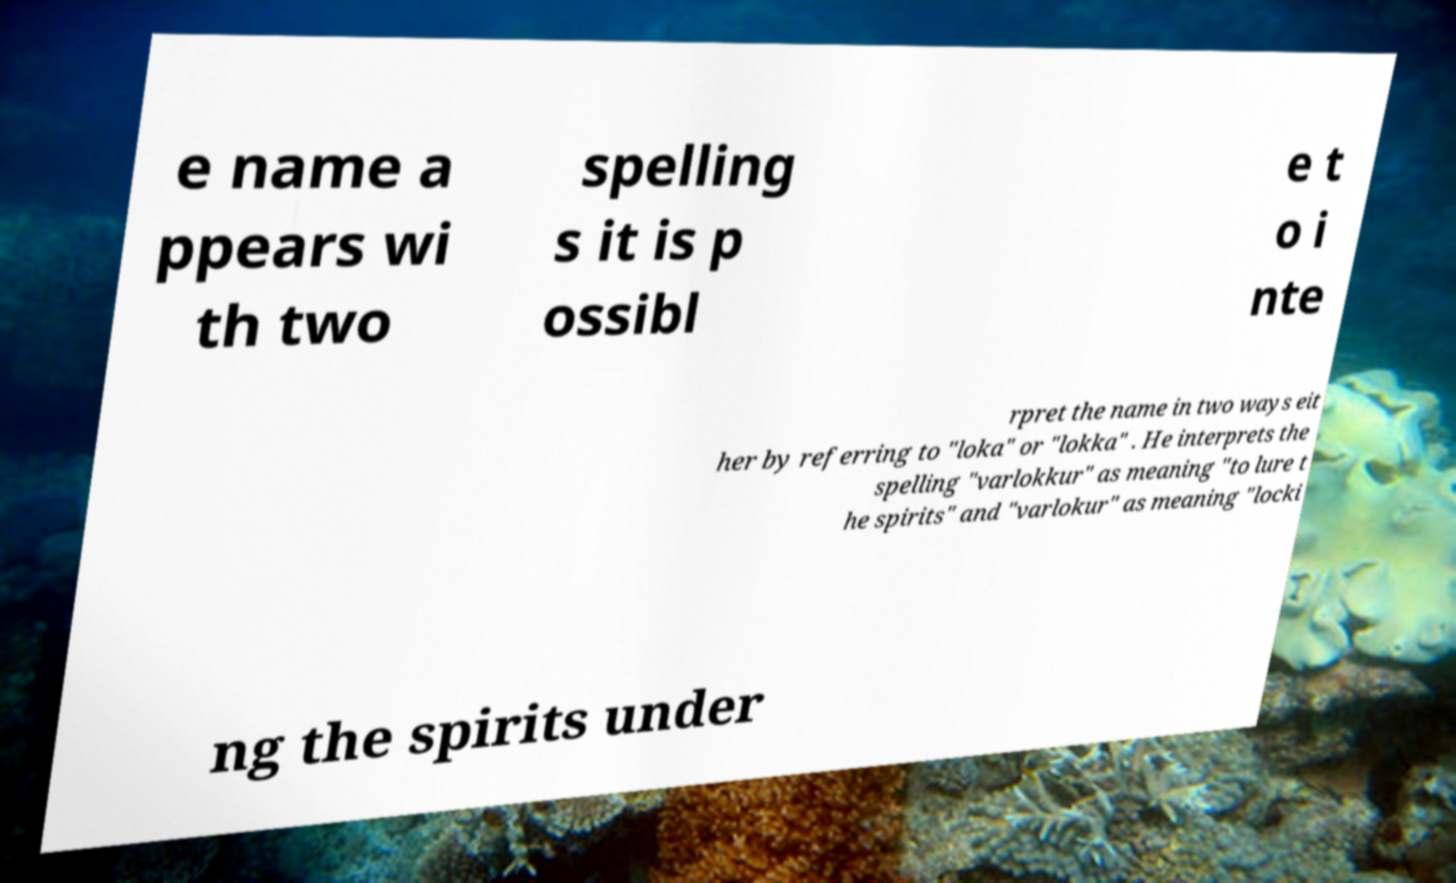There's text embedded in this image that I need extracted. Can you transcribe it verbatim? e name a ppears wi th two spelling s it is p ossibl e t o i nte rpret the name in two ways eit her by referring to "loka" or "lokka" . He interprets the spelling "varlokkur" as meaning "to lure t he spirits" and "varlokur" as meaning "locki ng the spirits under 